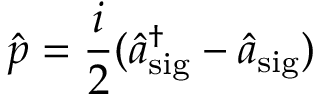<formula> <loc_0><loc_0><loc_500><loc_500>\hat { p } = \frac { i } { 2 } ( \hat { a } _ { s i g } ^ { \dagger } - \hat { a } _ { s i g } )</formula> 